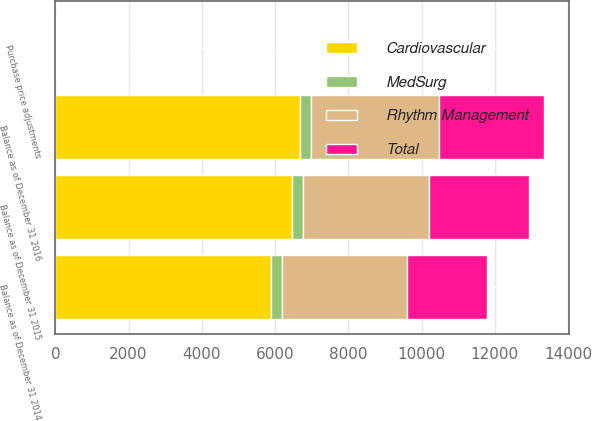Convert chart to OTSL. <chart><loc_0><loc_0><loc_500><loc_500><stacked_bar_chart><ecel><fcel>Balance as of December 31 2014<fcel>Purchase price adjustments<fcel>Balance as of December 31 2015<fcel>Balance as of December 31 2016<nl><fcel>Rhythm Management<fcel>3426<fcel>2<fcel>3451<fcel>3513<nl><fcel>MedSurg<fcel>290<fcel>2<fcel>292<fcel>290<nl><fcel>Total<fcel>2182<fcel>2<fcel>2730<fcel>2875<nl><fcel>Cardiovascular<fcel>5898<fcel>2<fcel>6473<fcel>6678<nl></chart> 